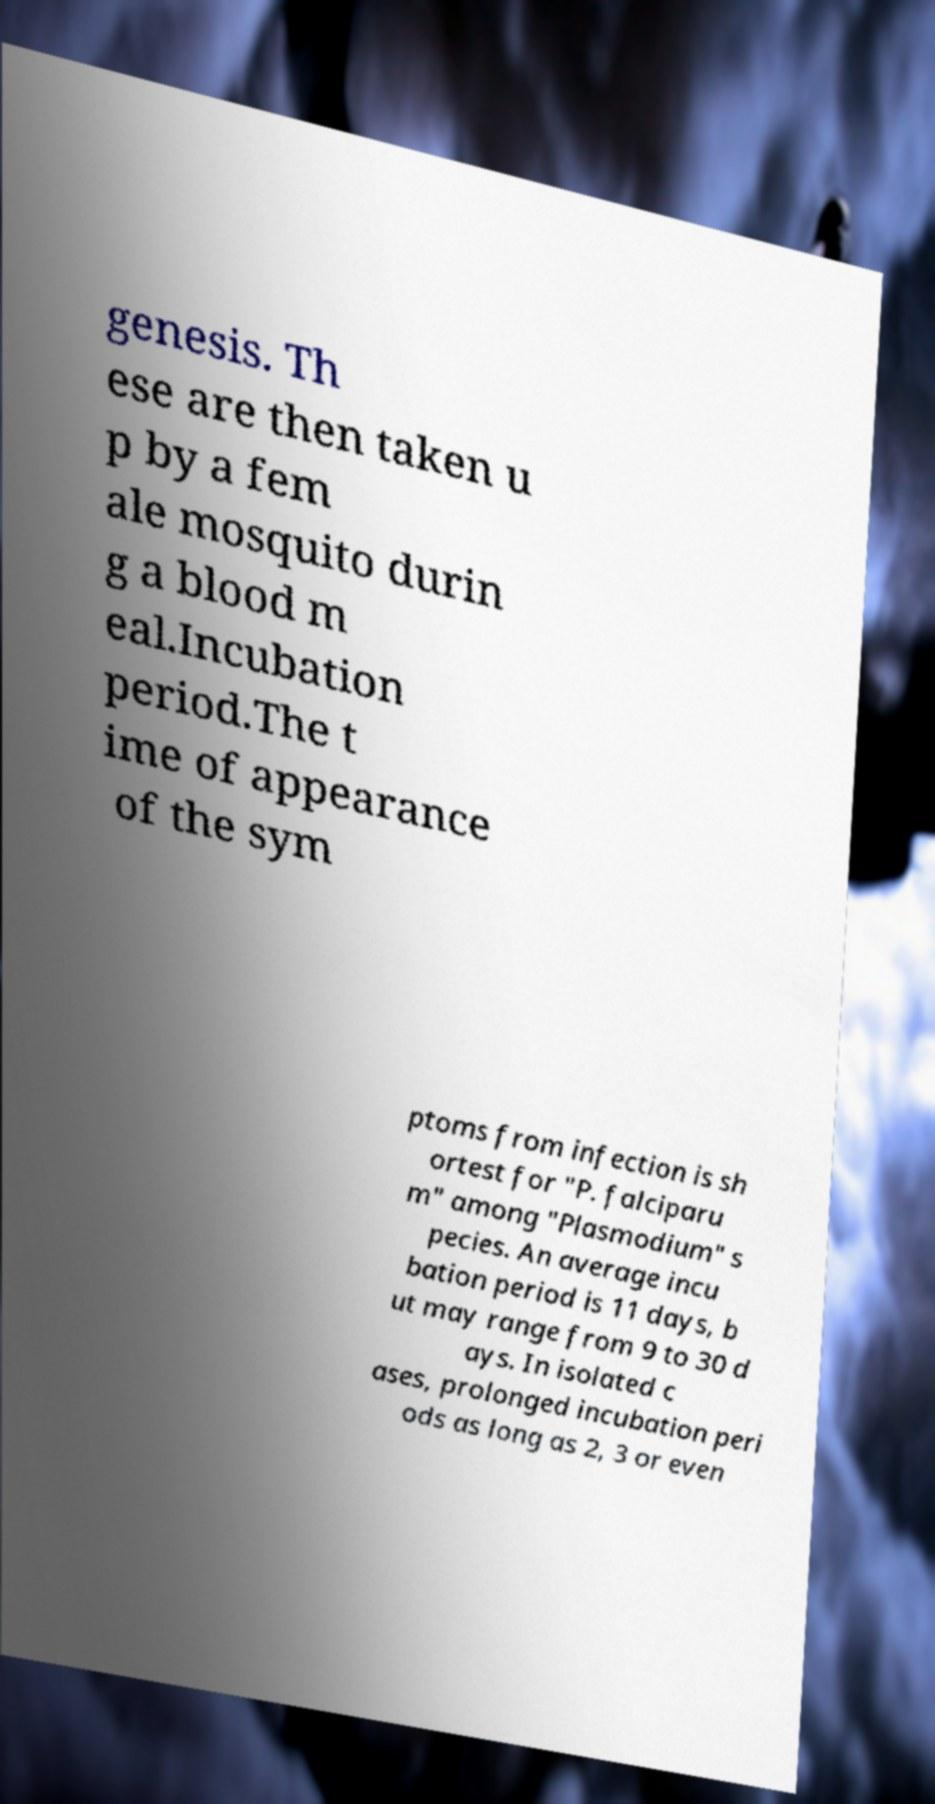There's text embedded in this image that I need extracted. Can you transcribe it verbatim? genesis. Th ese are then taken u p by a fem ale mosquito durin g a blood m eal.Incubation period.The t ime of appearance of the sym ptoms from infection is sh ortest for "P. falciparu m" among "Plasmodium" s pecies. An average incu bation period is 11 days, b ut may range from 9 to 30 d ays. In isolated c ases, prolonged incubation peri ods as long as 2, 3 or even 